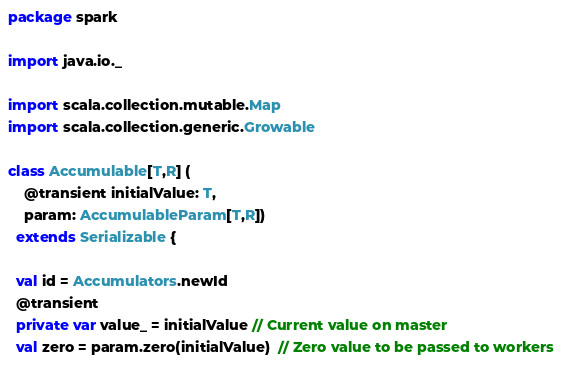<code> <loc_0><loc_0><loc_500><loc_500><_Scala_>package spark

import java.io._

import scala.collection.mutable.Map
import scala.collection.generic.Growable

class Accumulable[T,R] (
    @transient initialValue: T,
    param: AccumulableParam[T,R])
  extends Serializable {
  
  val id = Accumulators.newId
  @transient
  private var value_ = initialValue // Current value on master
  val zero = param.zero(initialValue)  // Zero value to be passed to workers</code> 